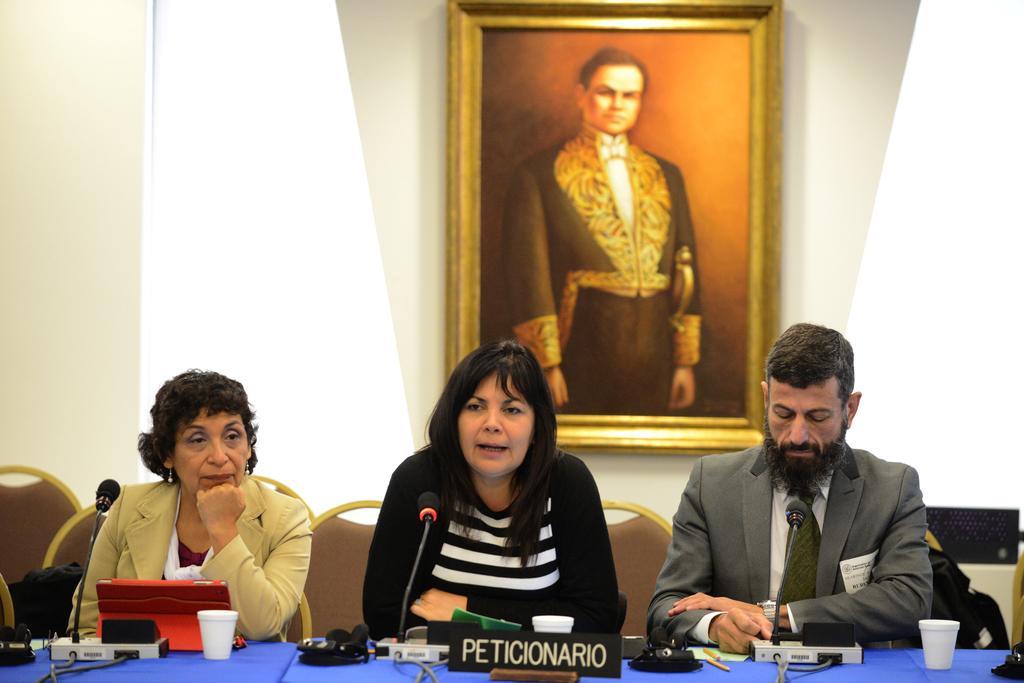Can you describe this image briefly? This picture is clicked inside the room. Here, we see three people are sitting in chair. Man on the right corner of the image wearing grey blazer is looking into the watch. Beside him, there is a man who is wearing black jacket, is talking on microphone. Beside her, there is another woman wearing cream blazer is sitting on the chair and in front of them, we see a table on which glass, microphone, cables are placed on it and behind them, we see a wall which is white in color and photo frame which is placed on it. 